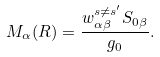Convert formula to latex. <formula><loc_0><loc_0><loc_500><loc_500>M _ { \alpha } ( R ) = \frac { w _ { \alpha \beta } ^ { s \ne s ^ { \prime } } S _ { 0 \beta } } { g _ { 0 } } .</formula> 